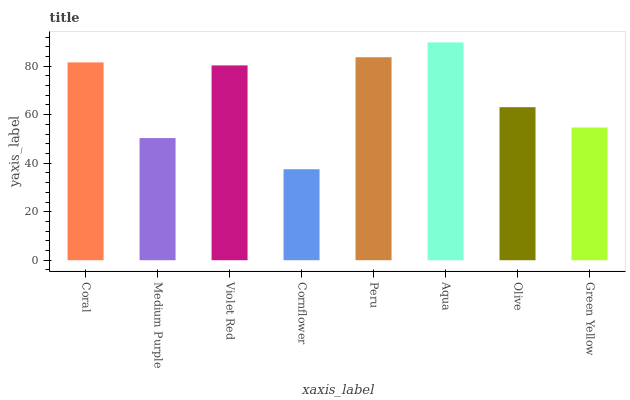Is Medium Purple the minimum?
Answer yes or no. No. Is Medium Purple the maximum?
Answer yes or no. No. Is Coral greater than Medium Purple?
Answer yes or no. Yes. Is Medium Purple less than Coral?
Answer yes or no. Yes. Is Medium Purple greater than Coral?
Answer yes or no. No. Is Coral less than Medium Purple?
Answer yes or no. No. Is Violet Red the high median?
Answer yes or no. Yes. Is Olive the low median?
Answer yes or no. Yes. Is Cornflower the high median?
Answer yes or no. No. Is Violet Red the low median?
Answer yes or no. No. 